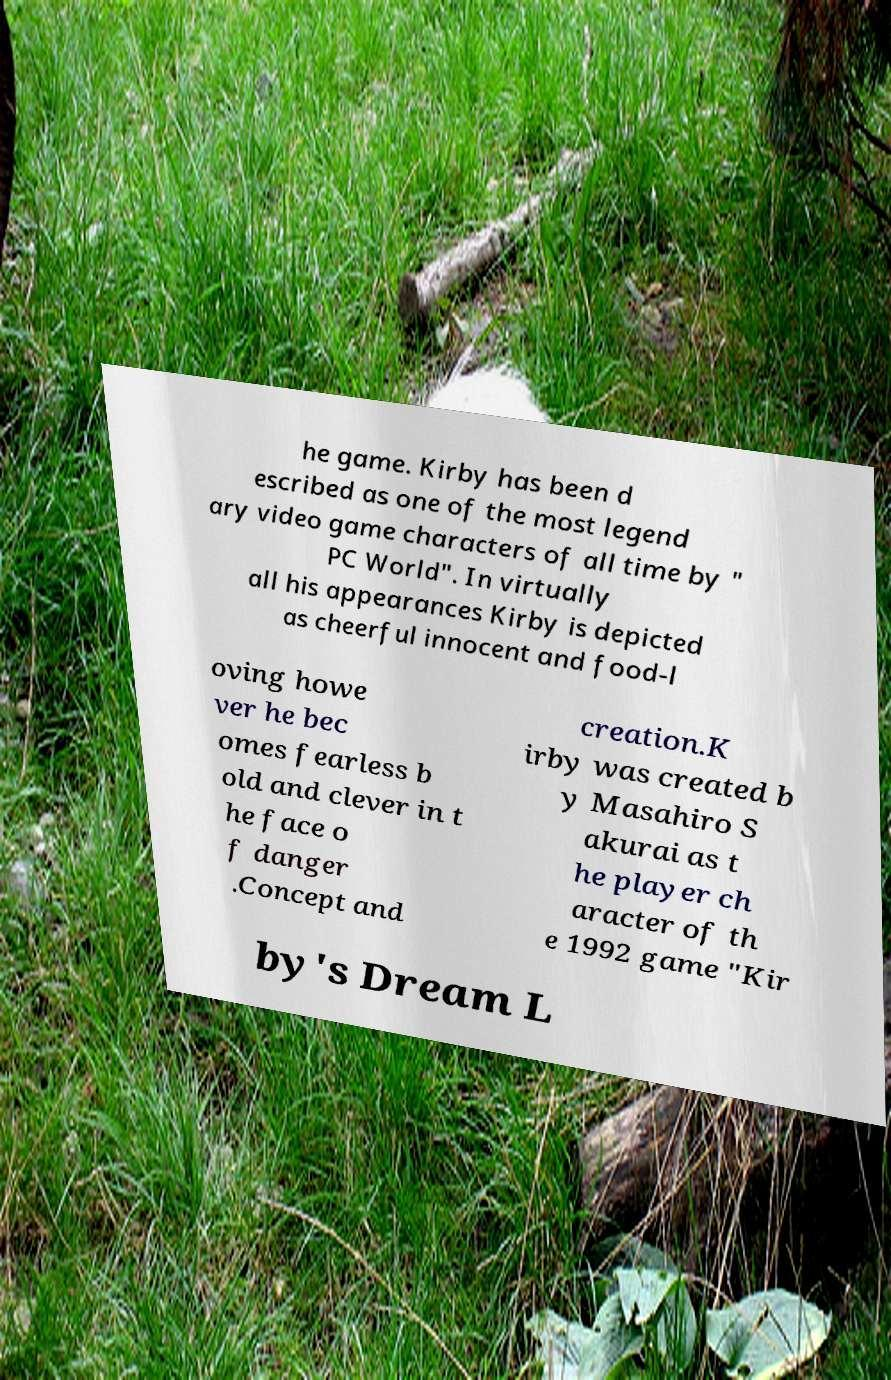Could you assist in decoding the text presented in this image and type it out clearly? he game. Kirby has been d escribed as one of the most legend ary video game characters of all time by " PC World". In virtually all his appearances Kirby is depicted as cheerful innocent and food-l oving howe ver he bec omes fearless b old and clever in t he face o f danger .Concept and creation.K irby was created b y Masahiro S akurai as t he player ch aracter of th e 1992 game "Kir by's Dream L 